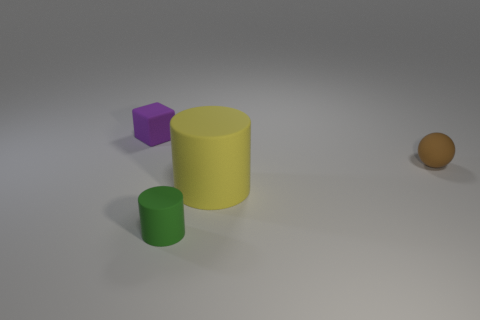Are there any other things that are the same size as the yellow cylinder?
Your answer should be compact. No. Is there anything else that is the same shape as the purple matte object?
Provide a short and direct response. No. There is a sphere that is the same material as the small cylinder; what is its color?
Make the answer very short. Brown. There is a tiny thing in front of the small object to the right of the tiny green thing; are there any large matte objects that are left of it?
Offer a terse response. No. Is the number of small purple blocks in front of the brown ball less than the number of objects that are in front of the small block?
Keep it short and to the point. Yes. How many big yellow objects are made of the same material as the small block?
Make the answer very short. 1. Is the size of the ball the same as the object behind the brown thing?
Keep it short and to the point. Yes. There is a yellow rubber cylinder that is in front of the tiny rubber thing that is on the right side of the small rubber object that is in front of the big yellow cylinder; how big is it?
Give a very brief answer. Large. Are there more matte things left of the tiny rubber cylinder than big yellow rubber cylinders behind the tiny purple rubber thing?
Keep it short and to the point. Yes. What number of cylinders are right of the matte cylinder that is to the left of the yellow rubber cylinder?
Ensure brevity in your answer.  1. 